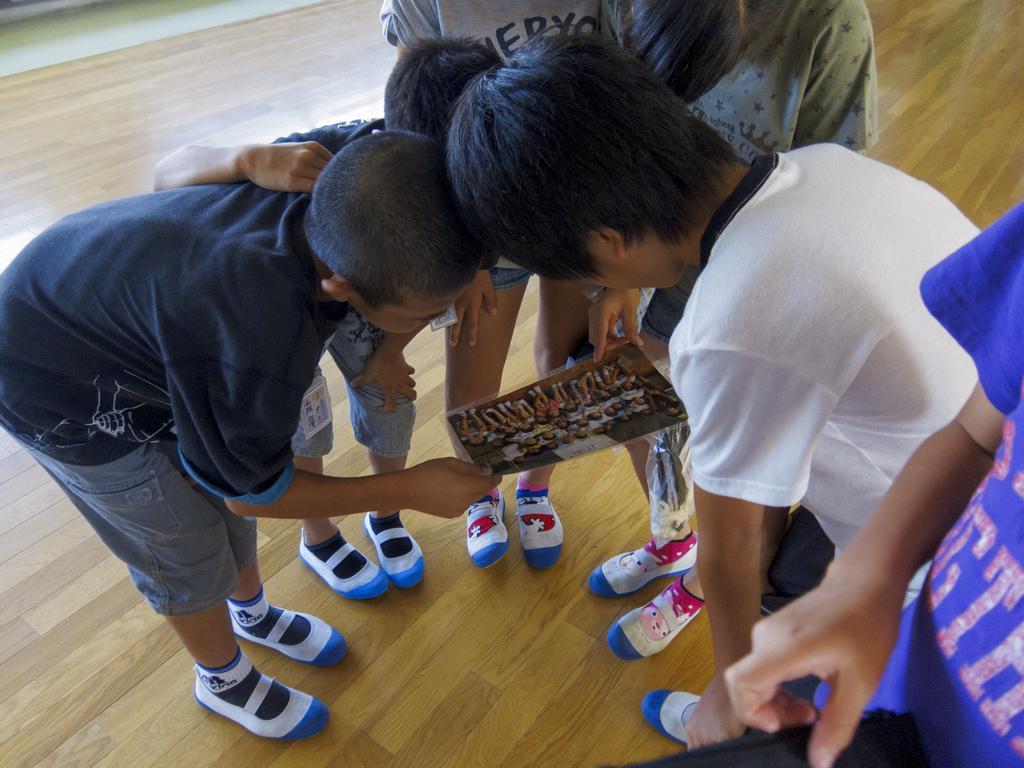How would you summarize this image in a sentence or two? In this picture there are group of children those who are standing in the center of the image, by holding a poster in there hands. 